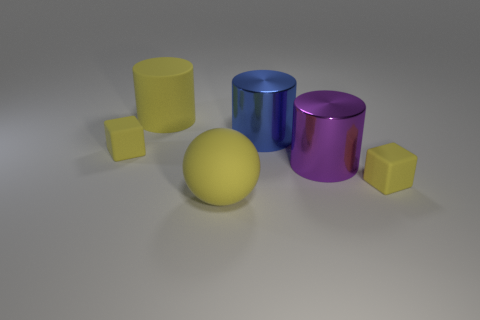What time of day does the lighting in the scene suggest? The lighting in the scene appears neutral; there are no strong indicators of a specific time of day. It looks like a controlled lighting environment, possibly indicative of a studio setup. 